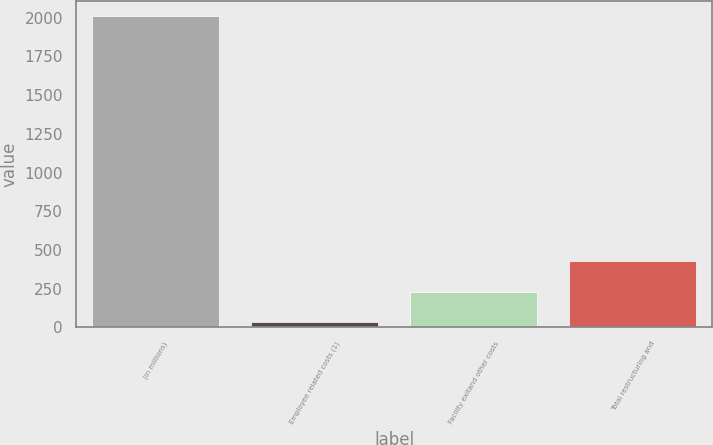Convert chart to OTSL. <chart><loc_0><loc_0><loc_500><loc_500><bar_chart><fcel>(in millions)<fcel>Employee related costs (1)<fcel>Facility exitand other costs<fcel>Total restructuring and<nl><fcel>2009<fcel>33.8<fcel>231.32<fcel>428.84<nl></chart> 